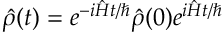<formula> <loc_0><loc_0><loc_500><loc_500>\hat { \rho } ( t ) = e ^ { - i \hat { H } t / } \hat { \rho } ( 0 ) e ^ { i \hat { H } t / }</formula> 